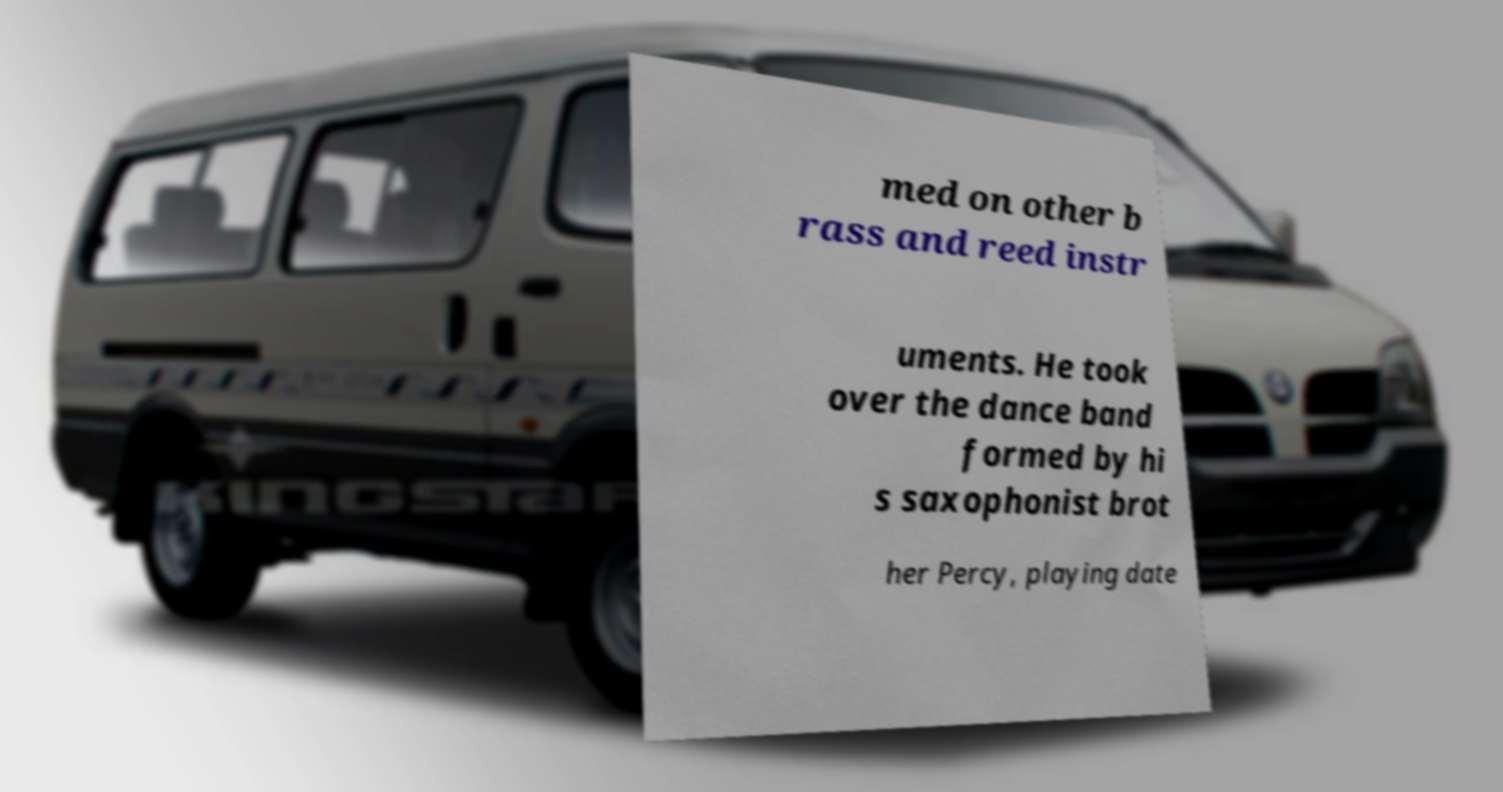Please read and relay the text visible in this image. What does it say? med on other b rass and reed instr uments. He took over the dance band formed by hi s saxophonist brot her Percy, playing date 